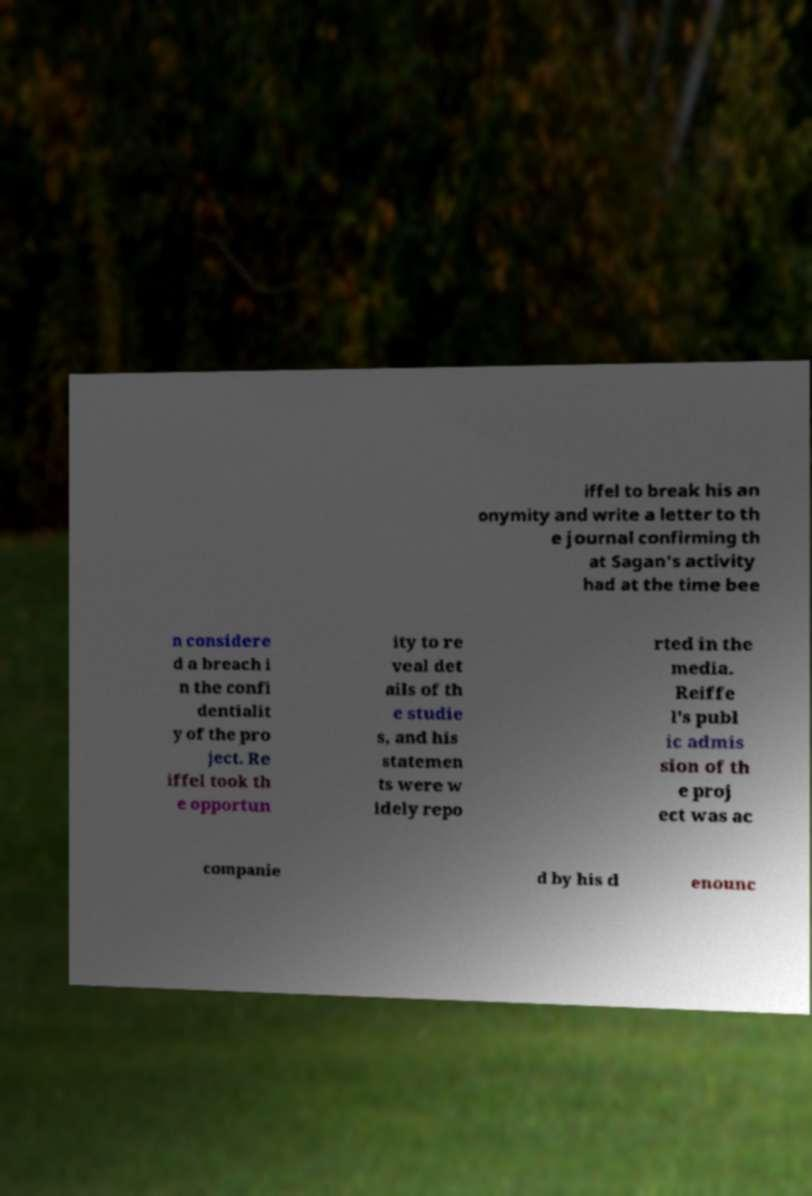Can you accurately transcribe the text from the provided image for me? iffel to break his an onymity and write a letter to th e journal confirming th at Sagan's activity had at the time bee n considere d a breach i n the confi dentialit y of the pro ject. Re iffel took th e opportun ity to re veal det ails of th e studie s, and his statemen ts were w idely repo rted in the media. Reiffe l's publ ic admis sion of th e proj ect was ac companie d by his d enounc 